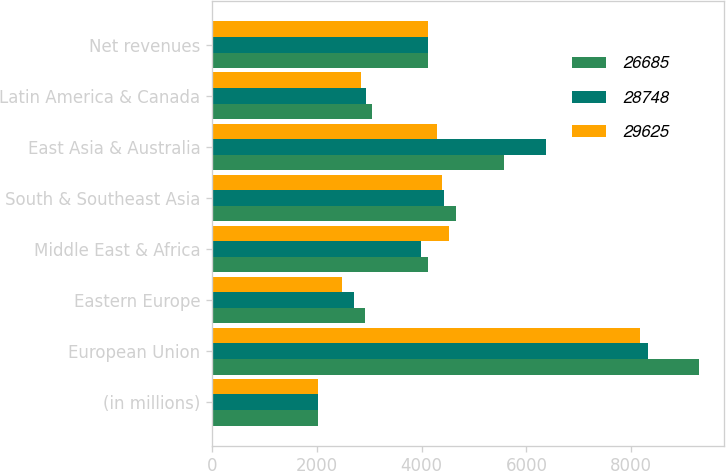Convert chart. <chart><loc_0><loc_0><loc_500><loc_500><stacked_bar_chart><ecel><fcel>(in millions)<fcel>European Union<fcel>Eastern Europe<fcel>Middle East & Africa<fcel>South & Southeast Asia<fcel>East Asia & Australia<fcel>Latin America & Canada<fcel>Net revenues<nl><fcel>26685<fcel>2018<fcel>9298<fcel>2921<fcel>4114<fcel>4656<fcel>5580<fcel>3056<fcel>4114<nl><fcel>28748<fcel>2017<fcel>8318<fcel>2711<fcel>3988<fcel>4417<fcel>6373<fcel>2941<fcel>4114<nl><fcel>29625<fcel>2016<fcel>8162<fcel>2484<fcel>4516<fcel>4396<fcel>4285<fcel>2842<fcel>4114<nl></chart> 